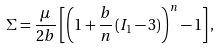<formula> <loc_0><loc_0><loc_500><loc_500>\Sigma = \frac { \mu } { 2 b } \left [ \left ( 1 + \frac { b } { n } \left ( I _ { 1 } - 3 \right ) \right ) ^ { n } - 1 \right ] ,</formula> 